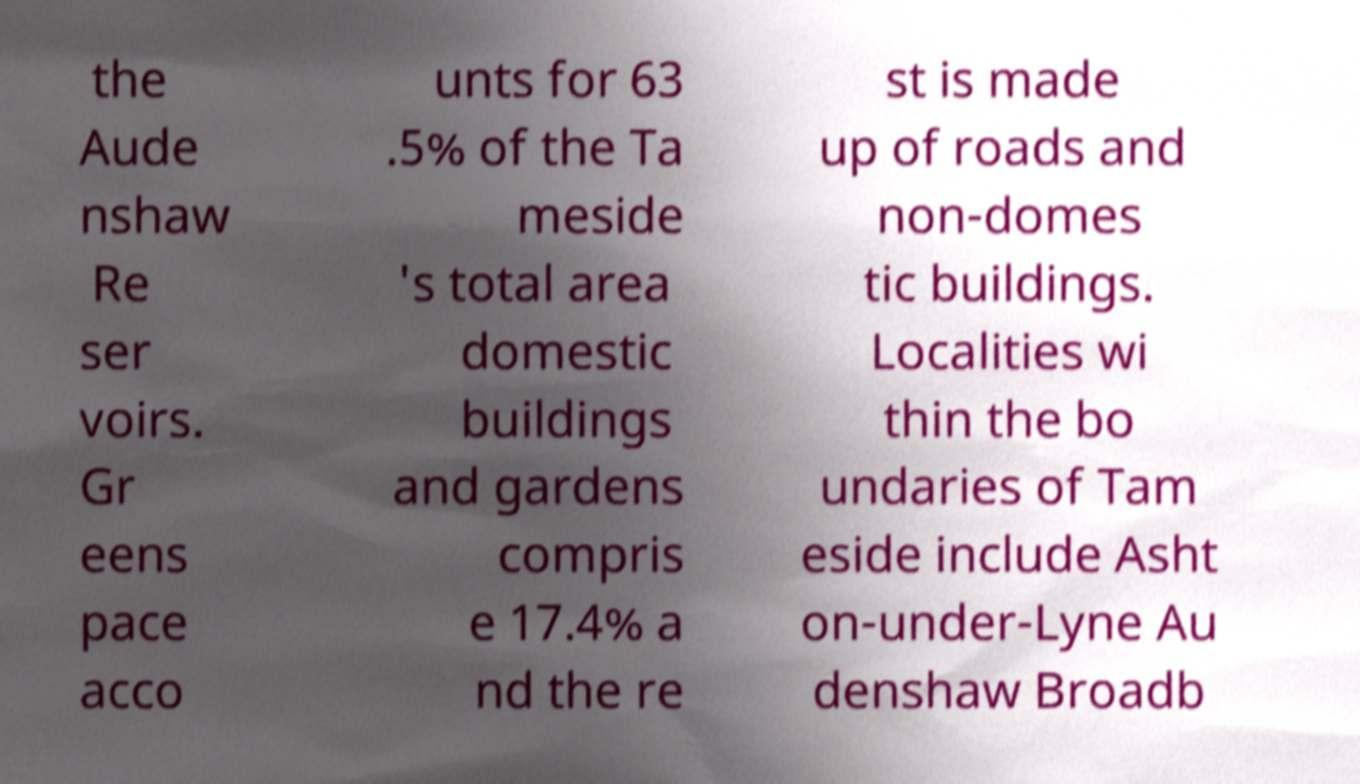Can you read and provide the text displayed in the image?This photo seems to have some interesting text. Can you extract and type it out for me? the Aude nshaw Re ser voirs. Gr eens pace acco unts for 63 .5% of the Ta meside 's total area domestic buildings and gardens compris e 17.4% a nd the re st is made up of roads and non-domes tic buildings. Localities wi thin the bo undaries of Tam eside include Asht on-under-Lyne Au denshaw Broadb 